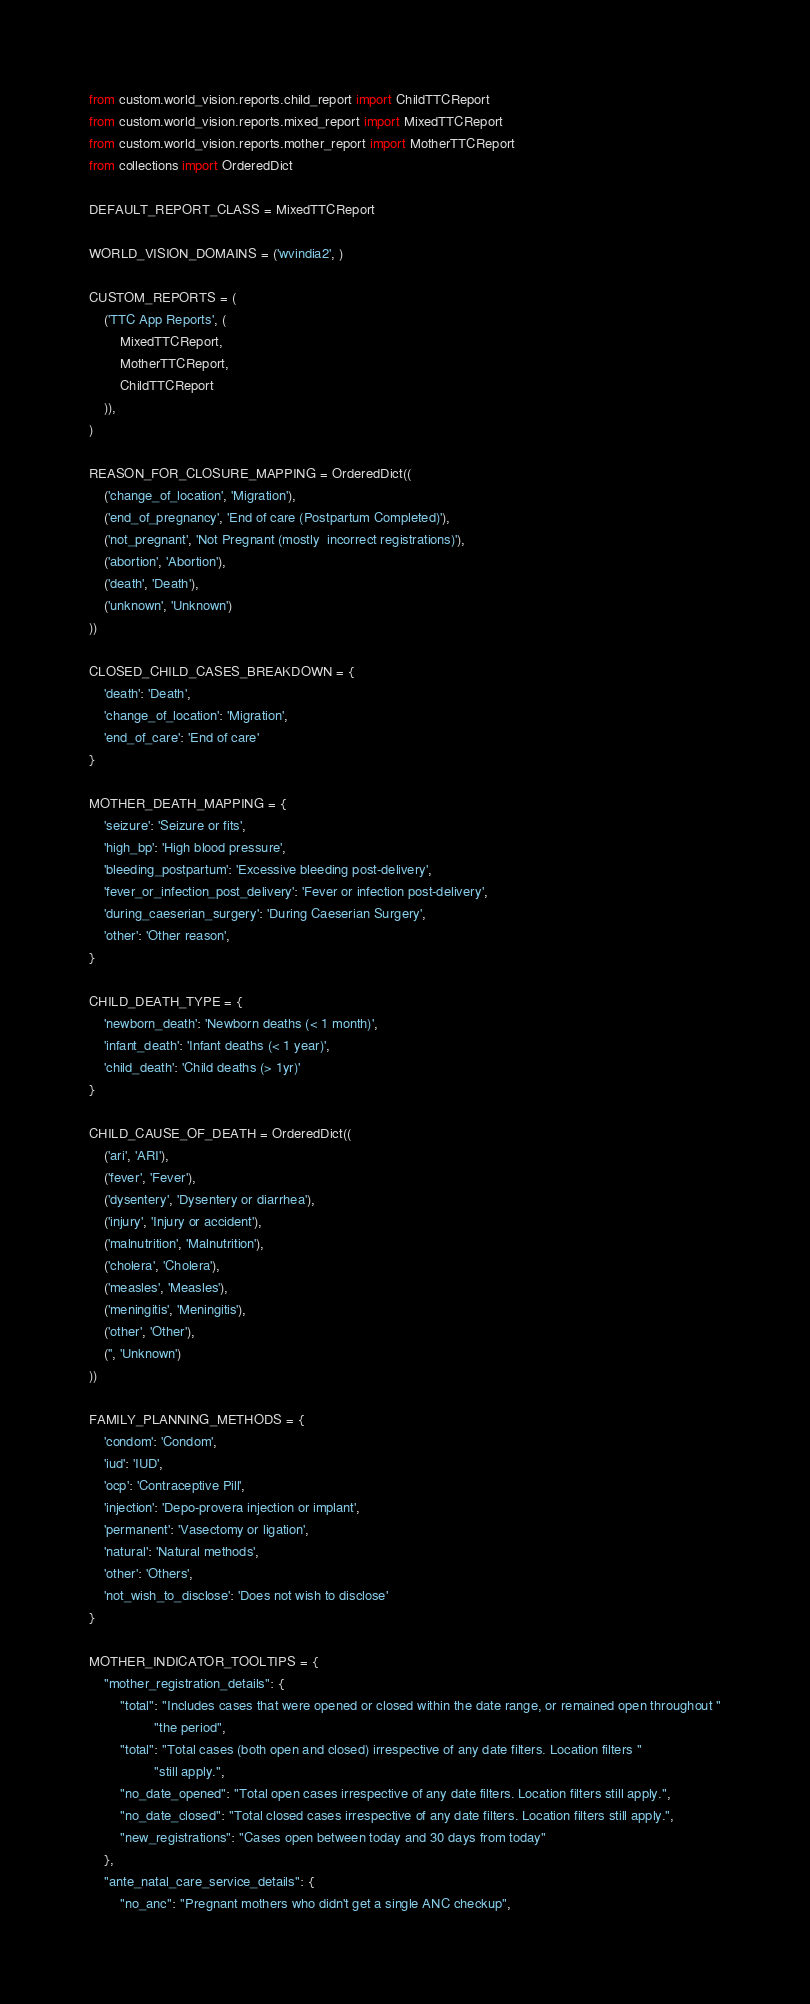Convert code to text. <code><loc_0><loc_0><loc_500><loc_500><_Python_>from custom.world_vision.reports.child_report import ChildTTCReport
from custom.world_vision.reports.mixed_report import MixedTTCReport
from custom.world_vision.reports.mother_report import MotherTTCReport
from collections import OrderedDict

DEFAULT_REPORT_CLASS = MixedTTCReport

WORLD_VISION_DOMAINS = ('wvindia2', )

CUSTOM_REPORTS = (
    ('TTC App Reports', (
        MixedTTCReport,
        MotherTTCReport,
        ChildTTCReport
    )),
)

REASON_FOR_CLOSURE_MAPPING = OrderedDict((
    ('change_of_location', 'Migration'),
    ('end_of_pregnancy', 'End of care (Postpartum Completed)'),
    ('not_pregnant', 'Not Pregnant (mostly  incorrect registrations)'),
    ('abortion', 'Abortion'),
    ('death', 'Death'),
    ('unknown', 'Unknown')
))

CLOSED_CHILD_CASES_BREAKDOWN = {
    'death': 'Death',
    'change_of_location': 'Migration',
    'end_of_care': 'End of care'
}

MOTHER_DEATH_MAPPING = {
    'seizure': 'Seizure or fits',
    'high_bp': 'High blood pressure',
    'bleeding_postpartum': 'Excessive bleeding post-delivery',
    'fever_or_infection_post_delivery': 'Fever or infection post-delivery',
    'during_caeserian_surgery': 'During Caeserian Surgery',
    'other': 'Other reason',
}

CHILD_DEATH_TYPE = {
    'newborn_death': 'Newborn deaths (< 1 month)',
    'infant_death': 'Infant deaths (< 1 year)',
    'child_death': 'Child deaths (> 1yr)'
}

CHILD_CAUSE_OF_DEATH = OrderedDict((
    ('ari', 'ARI'),
    ('fever', 'Fever'),
    ('dysentery', 'Dysentery or diarrhea'),
    ('injury', 'Injury or accident'),
    ('malnutrition', 'Malnutrition'),
    ('cholera', 'Cholera'),
    ('measles', 'Measles'),
    ('meningitis', 'Meningitis'),
    ('other', 'Other'),
    ('', 'Unknown')
))

FAMILY_PLANNING_METHODS = {
    'condom': 'Condom',
    'iud': 'IUD',
    'ocp': 'Contraceptive Pill',
    'injection': 'Depo-provera injection or implant',
    'permanent': 'Vasectomy or ligation',
    'natural': 'Natural methods',
    'other': 'Others',
    'not_wish_to_disclose': 'Does not wish to disclose'
}

MOTHER_INDICATOR_TOOLTIPS = {
    "mother_registration_details": {
        "total": "Includes cases that were opened or closed within the date range, or remained open throughout "
                 "the period",
        "total": "Total cases (both open and closed) irrespective of any date filters. Location filters "
                 "still apply.",
        "no_date_opened": "Total open cases irrespective of any date filters. Location filters still apply.",
        "no_date_closed": "Total closed cases irrespective of any date filters. Location filters still apply.",
        "new_registrations": "Cases open between today and 30 days from today"
    },
    "ante_natal_care_service_details": {
        "no_anc": "Pregnant mothers who didn't get a single ANC checkup",</code> 